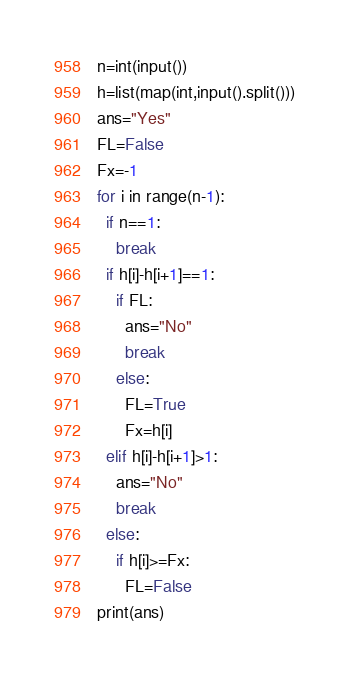<code> <loc_0><loc_0><loc_500><loc_500><_Python_>n=int(input())
h=list(map(int,input().split()))
ans="Yes"
FL=False
Fx=-1
for i in range(n-1):
  if n==1:
    break
  if h[i]-h[i+1]==1:
    if FL:
      ans="No"
      break  
    else:
      FL=True
      Fx=h[i]
  elif h[i]-h[i+1]>1:
    ans="No"
    break  
  else:
    if h[i]>=Fx:
      FL=False
print(ans)</code> 